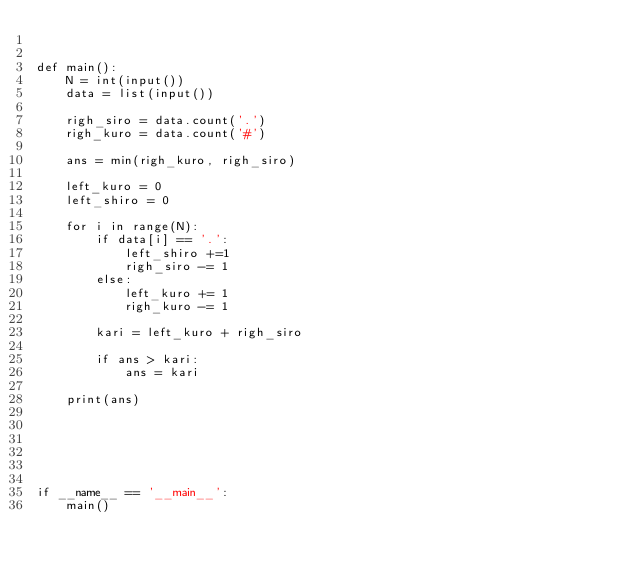<code> <loc_0><loc_0><loc_500><loc_500><_Python_>

def main():
    N = int(input())
    data = list(input())

    righ_siro = data.count('.')
    righ_kuro = data.count('#')

    ans = min(righ_kuro, righ_siro)

    left_kuro = 0
    left_shiro = 0

    for i in range(N):
        if data[i] == '.':
            left_shiro +=1
            righ_siro -= 1
        else:
            left_kuro += 1
            righ_kuro -= 1

        kari = left_kuro + righ_siro

        if ans > kari:
            ans = kari

    print(ans)






if __name__ == '__main__':
    main()
</code> 